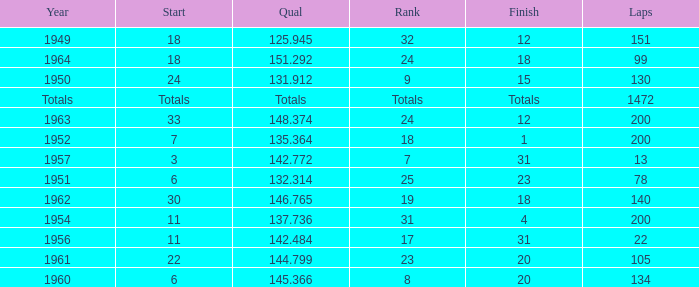Name the rank for laps less than 130 and year of 1951 25.0. 